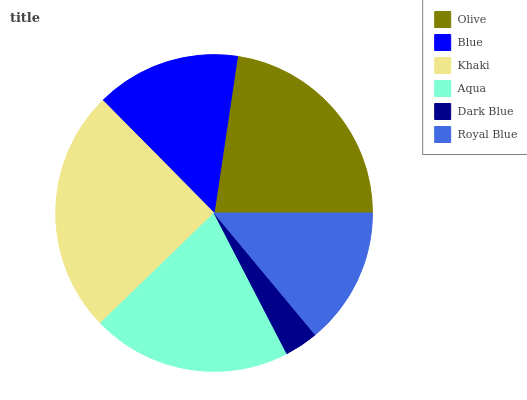Is Dark Blue the minimum?
Answer yes or no. Yes. Is Khaki the maximum?
Answer yes or no. Yes. Is Blue the minimum?
Answer yes or no. No. Is Blue the maximum?
Answer yes or no. No. Is Olive greater than Blue?
Answer yes or no. Yes. Is Blue less than Olive?
Answer yes or no. Yes. Is Blue greater than Olive?
Answer yes or no. No. Is Olive less than Blue?
Answer yes or no. No. Is Aqua the high median?
Answer yes or no. Yes. Is Blue the low median?
Answer yes or no. Yes. Is Dark Blue the high median?
Answer yes or no. No. Is Olive the low median?
Answer yes or no. No. 